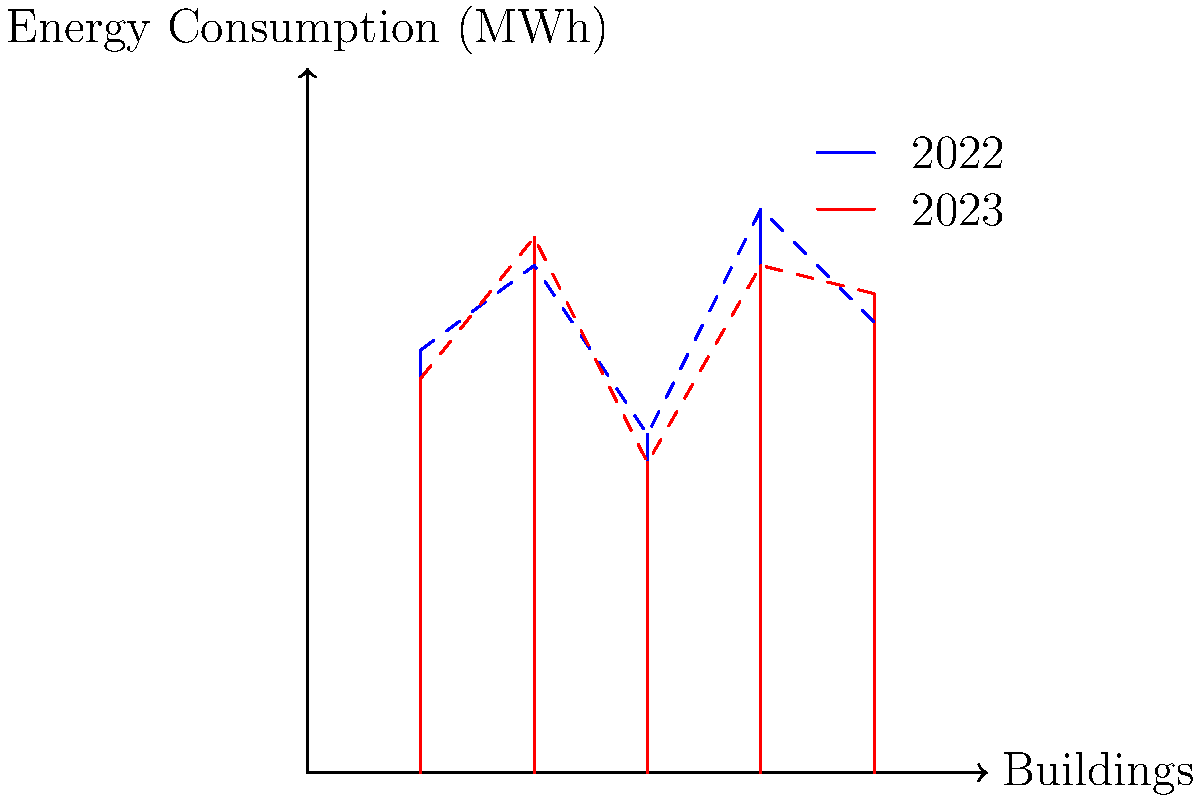As a technology vendor representative collaborating with the dean to provide energy management solutions, analyze the graph showing energy consumption patterns across five campus buildings for 2022 and 2023. What percentage of buildings showed a decrease in energy consumption from 2022 to 2023, and which building had the most significant increase in consumption? To answer this question, we need to analyze the data for each building:

1. Compare 2022 (blue) and 2023 (red) consumption for each building:
   Building 1: Decreased
   Building 2: Increased
   Building 3: Decreased
   Building 4: Decreased
   Building 5: Increased

2. Calculate the percentage of buildings with decreased consumption:
   3 out of 5 buildings decreased
   Percentage = (3 / 5) * 100 = 60%

3. Identify the building with the most significant increase:
   Building 2: Increased from about 180 MWh to 190 MWh (+10 MWh)
   Building 5: Increased from about 160 MWh to 170 MWh (+10 MWh)

   Both Building 2 and 5 show the same increase, but Building 2 had a higher overall consumption in both years.

Therefore, 60% of buildings showed a decrease in energy consumption, and Building 2 had the most significant increase in terms of absolute consumption.
Answer: 60% of buildings decreased; Building 2 had the most significant increase. 